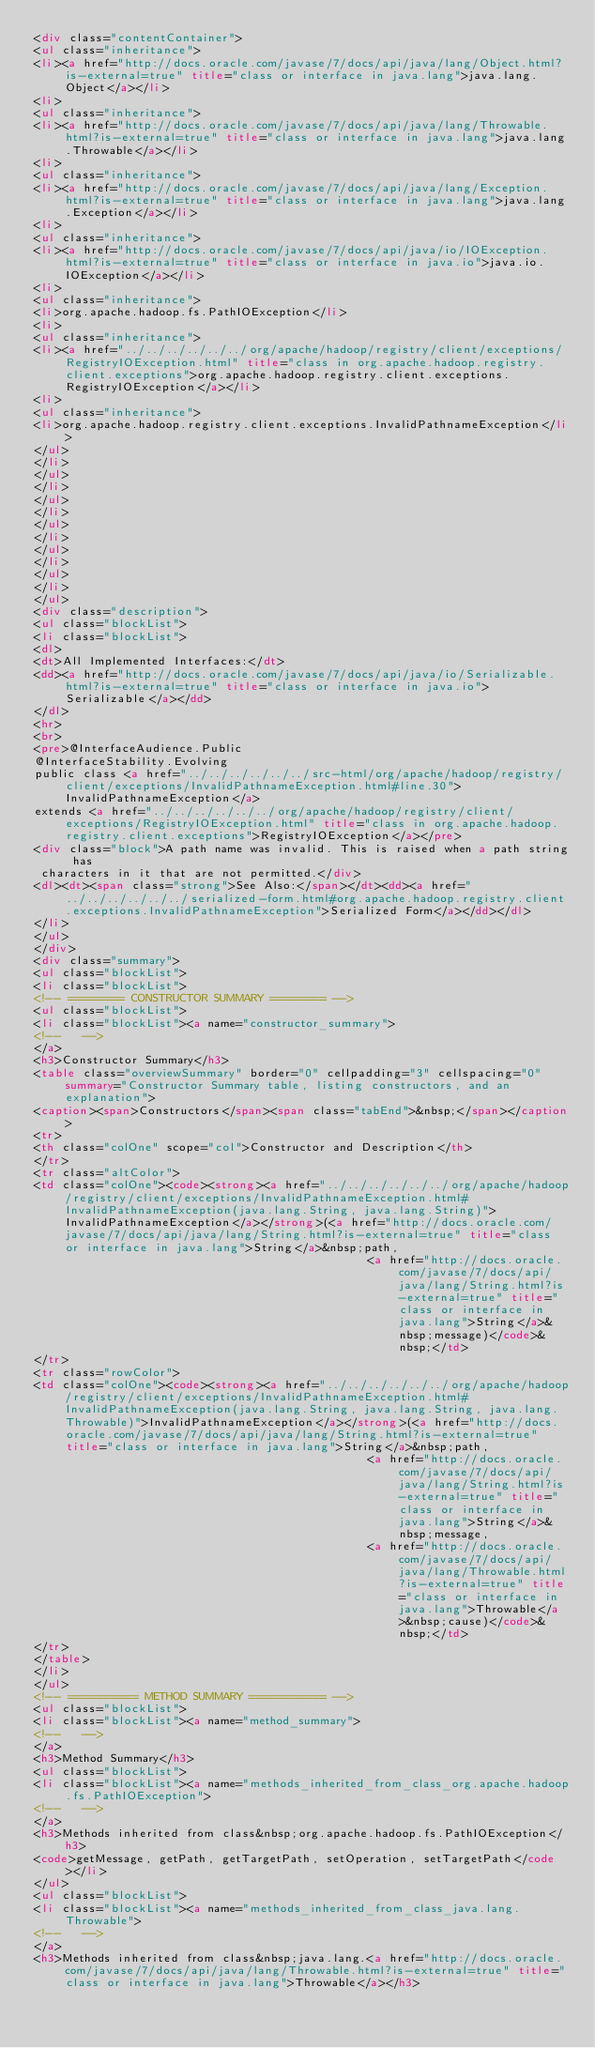<code> <loc_0><loc_0><loc_500><loc_500><_HTML_><div class="contentContainer">
<ul class="inheritance">
<li><a href="http://docs.oracle.com/javase/7/docs/api/java/lang/Object.html?is-external=true" title="class or interface in java.lang">java.lang.Object</a></li>
<li>
<ul class="inheritance">
<li><a href="http://docs.oracle.com/javase/7/docs/api/java/lang/Throwable.html?is-external=true" title="class or interface in java.lang">java.lang.Throwable</a></li>
<li>
<ul class="inheritance">
<li><a href="http://docs.oracle.com/javase/7/docs/api/java/lang/Exception.html?is-external=true" title="class or interface in java.lang">java.lang.Exception</a></li>
<li>
<ul class="inheritance">
<li><a href="http://docs.oracle.com/javase/7/docs/api/java/io/IOException.html?is-external=true" title="class or interface in java.io">java.io.IOException</a></li>
<li>
<ul class="inheritance">
<li>org.apache.hadoop.fs.PathIOException</li>
<li>
<ul class="inheritance">
<li><a href="../../../../../../org/apache/hadoop/registry/client/exceptions/RegistryIOException.html" title="class in org.apache.hadoop.registry.client.exceptions">org.apache.hadoop.registry.client.exceptions.RegistryIOException</a></li>
<li>
<ul class="inheritance">
<li>org.apache.hadoop.registry.client.exceptions.InvalidPathnameException</li>
</ul>
</li>
</ul>
</li>
</ul>
</li>
</ul>
</li>
</ul>
</li>
</ul>
</li>
</ul>
<div class="description">
<ul class="blockList">
<li class="blockList">
<dl>
<dt>All Implemented Interfaces:</dt>
<dd><a href="http://docs.oracle.com/javase/7/docs/api/java/io/Serializable.html?is-external=true" title="class or interface in java.io">Serializable</a></dd>
</dl>
<hr>
<br>
<pre>@InterfaceAudience.Public
@InterfaceStability.Evolving
public class <a href="../../../../../../src-html/org/apache/hadoop/registry/client/exceptions/InvalidPathnameException.html#line.30">InvalidPathnameException</a>
extends <a href="../../../../../../org/apache/hadoop/registry/client/exceptions/RegistryIOException.html" title="class in org.apache.hadoop.registry.client.exceptions">RegistryIOException</a></pre>
<div class="block">A path name was invalid. This is raised when a path string has
 characters in it that are not permitted.</div>
<dl><dt><span class="strong">See Also:</span></dt><dd><a href="../../../../../../serialized-form.html#org.apache.hadoop.registry.client.exceptions.InvalidPathnameException">Serialized Form</a></dd></dl>
</li>
</ul>
</div>
<div class="summary">
<ul class="blockList">
<li class="blockList">
<!-- ======== CONSTRUCTOR SUMMARY ======== -->
<ul class="blockList">
<li class="blockList"><a name="constructor_summary">
<!--   -->
</a>
<h3>Constructor Summary</h3>
<table class="overviewSummary" border="0" cellpadding="3" cellspacing="0" summary="Constructor Summary table, listing constructors, and an explanation">
<caption><span>Constructors</span><span class="tabEnd">&nbsp;</span></caption>
<tr>
<th class="colOne" scope="col">Constructor and Description</th>
</tr>
<tr class="altColor">
<td class="colOne"><code><strong><a href="../../../../../../org/apache/hadoop/registry/client/exceptions/InvalidPathnameException.html#InvalidPathnameException(java.lang.String, java.lang.String)">InvalidPathnameException</a></strong>(<a href="http://docs.oracle.com/javase/7/docs/api/java/lang/String.html?is-external=true" title="class or interface in java.lang">String</a>&nbsp;path,
                                                <a href="http://docs.oracle.com/javase/7/docs/api/java/lang/String.html?is-external=true" title="class or interface in java.lang">String</a>&nbsp;message)</code>&nbsp;</td>
</tr>
<tr class="rowColor">
<td class="colOne"><code><strong><a href="../../../../../../org/apache/hadoop/registry/client/exceptions/InvalidPathnameException.html#InvalidPathnameException(java.lang.String, java.lang.String, java.lang.Throwable)">InvalidPathnameException</a></strong>(<a href="http://docs.oracle.com/javase/7/docs/api/java/lang/String.html?is-external=true" title="class or interface in java.lang">String</a>&nbsp;path,
                                                <a href="http://docs.oracle.com/javase/7/docs/api/java/lang/String.html?is-external=true" title="class or interface in java.lang">String</a>&nbsp;message,
                                                <a href="http://docs.oracle.com/javase/7/docs/api/java/lang/Throwable.html?is-external=true" title="class or interface in java.lang">Throwable</a>&nbsp;cause)</code>&nbsp;</td>
</tr>
</table>
</li>
</ul>
<!-- ========== METHOD SUMMARY =========== -->
<ul class="blockList">
<li class="blockList"><a name="method_summary">
<!--   -->
</a>
<h3>Method Summary</h3>
<ul class="blockList">
<li class="blockList"><a name="methods_inherited_from_class_org.apache.hadoop.fs.PathIOException">
<!--   -->
</a>
<h3>Methods inherited from class&nbsp;org.apache.hadoop.fs.PathIOException</h3>
<code>getMessage, getPath, getTargetPath, setOperation, setTargetPath</code></li>
</ul>
<ul class="blockList">
<li class="blockList"><a name="methods_inherited_from_class_java.lang.Throwable">
<!--   -->
</a>
<h3>Methods inherited from class&nbsp;java.lang.<a href="http://docs.oracle.com/javase/7/docs/api/java/lang/Throwable.html?is-external=true" title="class or interface in java.lang">Throwable</a></h3></code> 